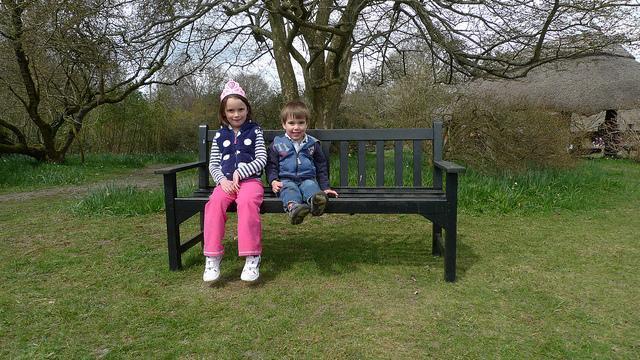How many people can be seen?
Give a very brief answer. 2. How many umbrellas are there?
Give a very brief answer. 0. 